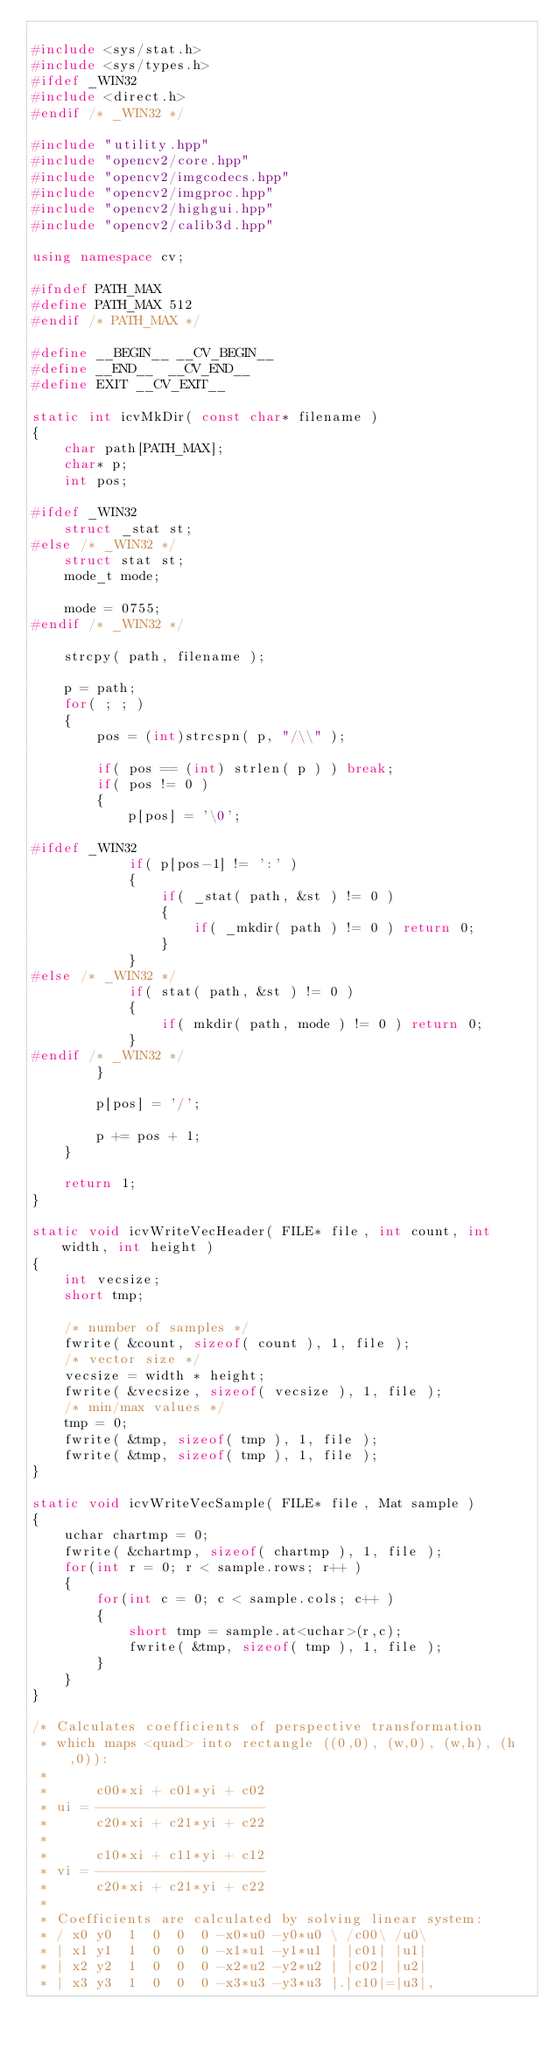<code> <loc_0><loc_0><loc_500><loc_500><_C++_>
#include <sys/stat.h>
#include <sys/types.h>
#ifdef _WIN32
#include <direct.h>
#endif /* _WIN32 */

#include "utility.hpp"
#include "opencv2/core.hpp"
#include "opencv2/imgcodecs.hpp"
#include "opencv2/imgproc.hpp"
#include "opencv2/highgui.hpp"
#include "opencv2/calib3d.hpp"

using namespace cv;

#ifndef PATH_MAX
#define PATH_MAX 512
#endif /* PATH_MAX */

#define __BEGIN__ __CV_BEGIN__
#define __END__  __CV_END__
#define EXIT __CV_EXIT__

static int icvMkDir( const char* filename )
{
    char path[PATH_MAX];
    char* p;
    int pos;

#ifdef _WIN32
    struct _stat st;
#else /* _WIN32 */
    struct stat st;
    mode_t mode;

    mode = 0755;
#endif /* _WIN32 */

    strcpy( path, filename );

    p = path;
    for( ; ; )
    {
        pos = (int)strcspn( p, "/\\" );

        if( pos == (int) strlen( p ) ) break;
        if( pos != 0 )
        {
            p[pos] = '\0';

#ifdef _WIN32
            if( p[pos-1] != ':' )
            {
                if( _stat( path, &st ) != 0 )
                {
                    if( _mkdir( path ) != 0 ) return 0;
                }
            }
#else /* _WIN32 */
            if( stat( path, &st ) != 0 )
            {
                if( mkdir( path, mode ) != 0 ) return 0;
            }
#endif /* _WIN32 */
        }

        p[pos] = '/';

        p += pos + 1;
    }

    return 1;
}

static void icvWriteVecHeader( FILE* file, int count, int width, int height )
{
    int vecsize;
    short tmp;

    /* number of samples */
    fwrite( &count, sizeof( count ), 1, file );
    /* vector size */
    vecsize = width * height;
    fwrite( &vecsize, sizeof( vecsize ), 1, file );
    /* min/max values */
    tmp = 0;
    fwrite( &tmp, sizeof( tmp ), 1, file );
    fwrite( &tmp, sizeof( tmp ), 1, file );
}

static void icvWriteVecSample( FILE* file, Mat sample )
{
    uchar chartmp = 0;
    fwrite( &chartmp, sizeof( chartmp ), 1, file );
    for(int r = 0; r < sample.rows; r++ )
    {
        for(int c = 0; c < sample.cols; c++ )
        {
            short tmp = sample.at<uchar>(r,c);
            fwrite( &tmp, sizeof( tmp ), 1, file );
        }
    }
}

/* Calculates coefficients of perspective transformation
 * which maps <quad> into rectangle ((0,0), (w,0), (w,h), (h,0)):
 *
 *      c00*xi + c01*yi + c02
 * ui = ---------------------
 *      c20*xi + c21*yi + c22
 *
 *      c10*xi + c11*yi + c12
 * vi = ---------------------
 *      c20*xi + c21*yi + c22
 *
 * Coefficients are calculated by solving linear system:
 * / x0 y0  1  0  0  0 -x0*u0 -y0*u0 \ /c00\ /u0\
 * | x1 y1  1  0  0  0 -x1*u1 -y1*u1 | |c01| |u1|
 * | x2 y2  1  0  0  0 -x2*u2 -y2*u2 | |c02| |u2|
 * | x3 y3  1  0  0  0 -x3*u3 -y3*u3 |.|c10|=|u3|,</code> 